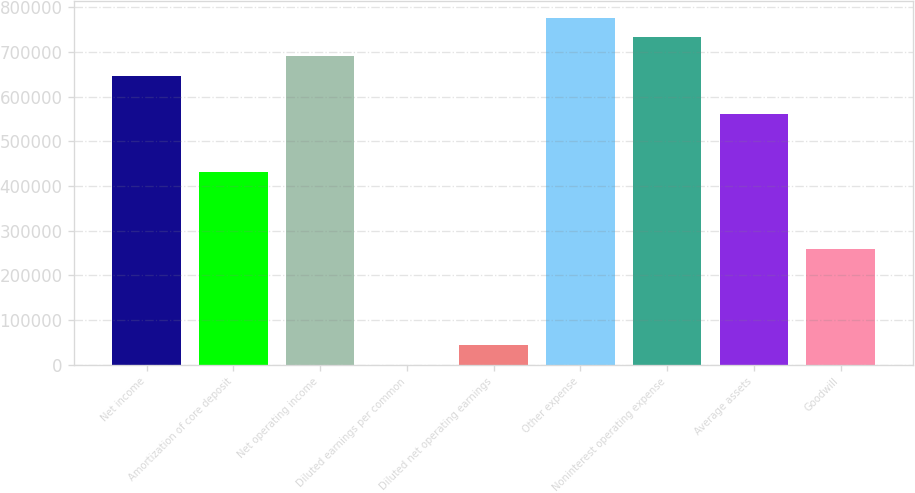<chart> <loc_0><loc_0><loc_500><loc_500><bar_chart><fcel>Net income<fcel>Amortization of core deposit<fcel>Net operating income<fcel>Diluted earnings per common<fcel>Diluted net operating earnings<fcel>Other expense<fcel>Noninterest operating expense<fcel>Average assets<fcel>Goodwill<nl><fcel>646720<fcel>431147<fcel>689835<fcel>1.1<fcel>43115.7<fcel>776064<fcel>732949<fcel>560491<fcel>258689<nl></chart> 